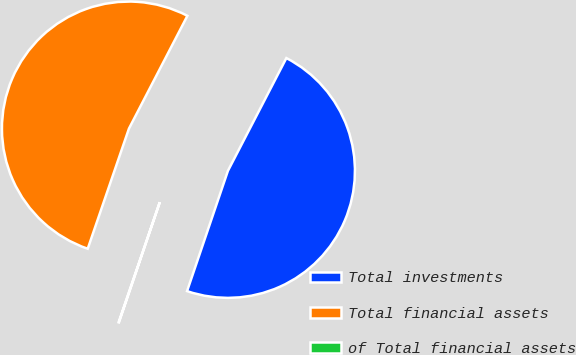Convert chart to OTSL. <chart><loc_0><loc_0><loc_500><loc_500><pie_chart><fcel>Total investments<fcel>Total financial assets<fcel>of Total financial assets<nl><fcel>47.6%<fcel>52.35%<fcel>0.05%<nl></chart> 